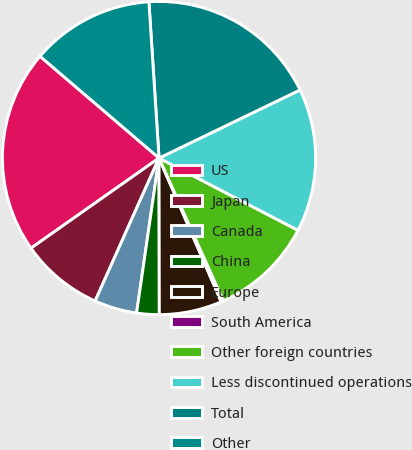Convert chart. <chart><loc_0><loc_0><loc_500><loc_500><pie_chart><fcel>US<fcel>Japan<fcel>Canada<fcel>China<fcel>Europe<fcel>South America<fcel>Other foreign countries<fcel>Less discontinued operations<fcel>Total<fcel>Other<nl><fcel>21.02%<fcel>8.55%<fcel>4.4%<fcel>2.32%<fcel>6.47%<fcel>0.24%<fcel>10.63%<fcel>14.79%<fcel>18.87%<fcel>12.71%<nl></chart> 